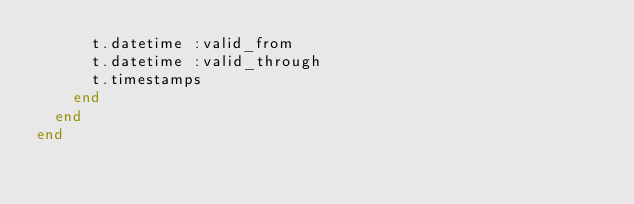<code> <loc_0><loc_0><loc_500><loc_500><_Ruby_>      t.datetime :valid_from
      t.datetime :valid_through
      t.timestamps
    end
  end
end
</code> 